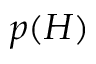Convert formula to latex. <formula><loc_0><loc_0><loc_500><loc_500>p ( H )</formula> 